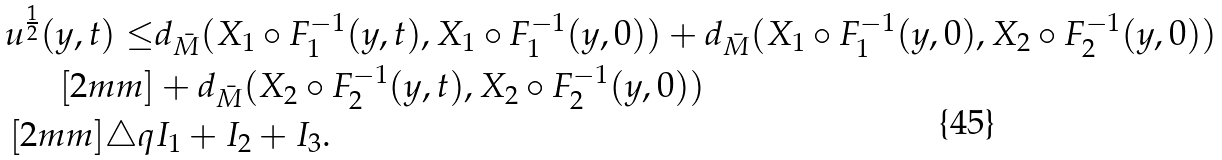Convert formula to latex. <formula><loc_0><loc_0><loc_500><loc_500>u ^ { \frac { 1 } { 2 } } ( y , t ) \leq & d _ { \bar { M } } ( { X } _ { 1 } \circ F _ { 1 } ^ { - 1 } ( y , t ) , { X } _ { 1 } \circ F _ { 1 } ^ { - 1 } ( y , 0 ) ) + d _ { \bar { M } } ( { X } _ { 1 } \circ F _ { 1 } ^ { - 1 } ( y , 0 ) , { X } _ { 2 } \circ F _ { 2 } ^ { - 1 } ( y , 0 ) ) \\ [ 2 m m ] & + d _ { \bar { M } } ( { X } _ { 2 } \circ F _ { 2 } ^ { - 1 } ( y , t ) , { X } _ { 2 } \circ F _ { 2 } ^ { - 1 } ( y , 0 ) ) \\ [ 2 m m ] \triangle q & I _ { 1 } + I _ { 2 } + I _ { 3 } .</formula> 